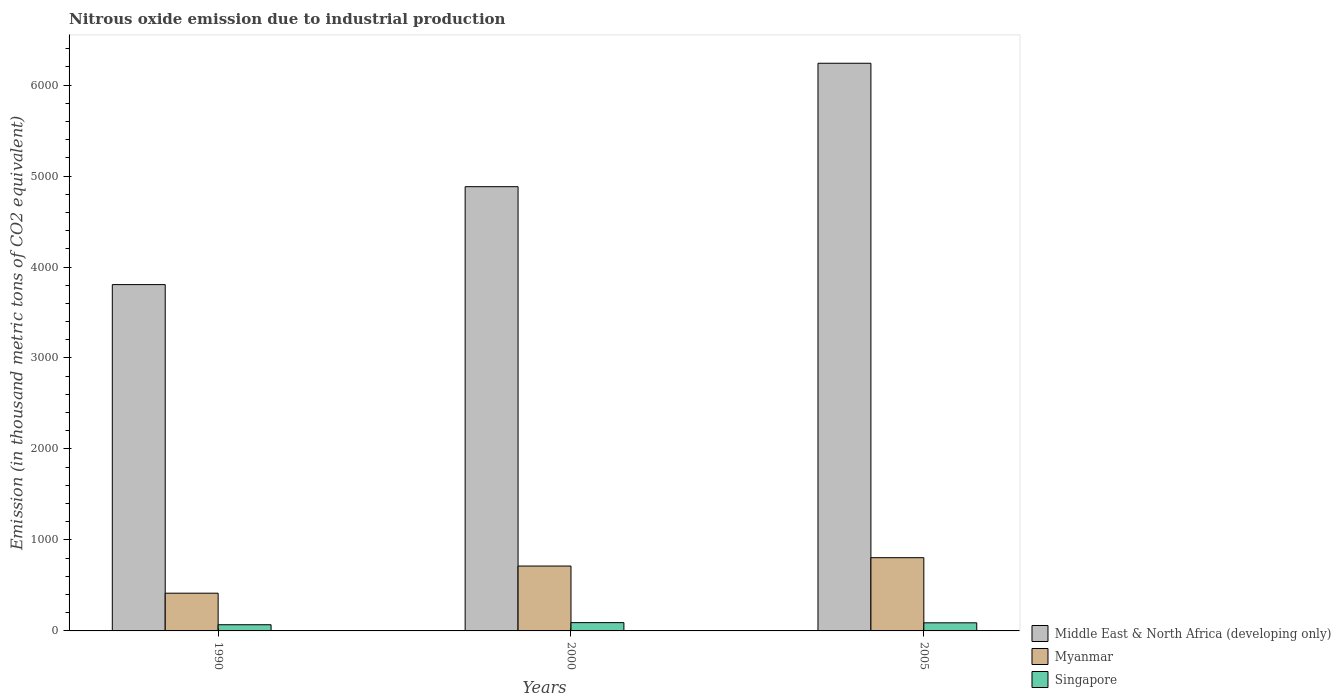How many groups of bars are there?
Provide a short and direct response. 3. Are the number of bars per tick equal to the number of legend labels?
Your response must be concise. Yes. Are the number of bars on each tick of the X-axis equal?
Your response must be concise. Yes. How many bars are there on the 1st tick from the left?
Ensure brevity in your answer.  3. How many bars are there on the 2nd tick from the right?
Your answer should be compact. 3. In how many cases, is the number of bars for a given year not equal to the number of legend labels?
Your response must be concise. 0. What is the amount of nitrous oxide emitted in Middle East & North Africa (developing only) in 2000?
Your response must be concise. 4882.9. Across all years, what is the maximum amount of nitrous oxide emitted in Myanmar?
Give a very brief answer. 804.8. Across all years, what is the minimum amount of nitrous oxide emitted in Middle East & North Africa (developing only)?
Offer a terse response. 3806.6. In which year was the amount of nitrous oxide emitted in Singapore maximum?
Give a very brief answer. 2000. What is the total amount of nitrous oxide emitted in Myanmar in the graph?
Give a very brief answer. 1932.6. What is the difference between the amount of nitrous oxide emitted in Singapore in 2000 and that in 2005?
Provide a short and direct response. 2.1. What is the difference between the amount of nitrous oxide emitted in Myanmar in 2000 and the amount of nitrous oxide emitted in Middle East & North Africa (developing only) in 1990?
Provide a succinct answer. -3093.5. What is the average amount of nitrous oxide emitted in Singapore per year?
Provide a succinct answer. 82.67. In the year 1990, what is the difference between the amount of nitrous oxide emitted in Myanmar and amount of nitrous oxide emitted in Middle East & North Africa (developing only)?
Give a very brief answer. -3391.9. In how many years, is the amount of nitrous oxide emitted in Middle East & North Africa (developing only) greater than 3000 thousand metric tons?
Offer a terse response. 3. What is the ratio of the amount of nitrous oxide emitted in Middle East & North Africa (developing only) in 1990 to that in 2005?
Keep it short and to the point. 0.61. Is the amount of nitrous oxide emitted in Myanmar in 1990 less than that in 2000?
Your answer should be very brief. Yes. What is the difference between the highest and the second highest amount of nitrous oxide emitted in Myanmar?
Offer a terse response. 91.7. What is the difference between the highest and the lowest amount of nitrous oxide emitted in Myanmar?
Make the answer very short. 390.1. What does the 3rd bar from the left in 2000 represents?
Your answer should be compact. Singapore. What does the 2nd bar from the right in 2005 represents?
Keep it short and to the point. Myanmar. Is it the case that in every year, the sum of the amount of nitrous oxide emitted in Singapore and amount of nitrous oxide emitted in Myanmar is greater than the amount of nitrous oxide emitted in Middle East & North Africa (developing only)?
Your answer should be very brief. No. Are all the bars in the graph horizontal?
Ensure brevity in your answer.  No. How many years are there in the graph?
Your answer should be very brief. 3. What is the difference between two consecutive major ticks on the Y-axis?
Provide a succinct answer. 1000. Does the graph contain grids?
Keep it short and to the point. No. What is the title of the graph?
Offer a very short reply. Nitrous oxide emission due to industrial production. Does "Romania" appear as one of the legend labels in the graph?
Give a very brief answer. No. What is the label or title of the X-axis?
Offer a very short reply. Years. What is the label or title of the Y-axis?
Ensure brevity in your answer.  Emission (in thousand metric tons of CO2 equivalent). What is the Emission (in thousand metric tons of CO2 equivalent) in Middle East & North Africa (developing only) in 1990?
Your response must be concise. 3806.6. What is the Emission (in thousand metric tons of CO2 equivalent) in Myanmar in 1990?
Your answer should be very brief. 414.7. What is the Emission (in thousand metric tons of CO2 equivalent) of Singapore in 1990?
Provide a succinct answer. 67.9. What is the Emission (in thousand metric tons of CO2 equivalent) of Middle East & North Africa (developing only) in 2000?
Your answer should be compact. 4882.9. What is the Emission (in thousand metric tons of CO2 equivalent) of Myanmar in 2000?
Offer a very short reply. 713.1. What is the Emission (in thousand metric tons of CO2 equivalent) of Singapore in 2000?
Ensure brevity in your answer.  91.1. What is the Emission (in thousand metric tons of CO2 equivalent) of Middle East & North Africa (developing only) in 2005?
Provide a short and direct response. 6239.6. What is the Emission (in thousand metric tons of CO2 equivalent) in Myanmar in 2005?
Your answer should be very brief. 804.8. What is the Emission (in thousand metric tons of CO2 equivalent) of Singapore in 2005?
Your response must be concise. 89. Across all years, what is the maximum Emission (in thousand metric tons of CO2 equivalent) in Middle East & North Africa (developing only)?
Provide a short and direct response. 6239.6. Across all years, what is the maximum Emission (in thousand metric tons of CO2 equivalent) in Myanmar?
Keep it short and to the point. 804.8. Across all years, what is the maximum Emission (in thousand metric tons of CO2 equivalent) of Singapore?
Keep it short and to the point. 91.1. Across all years, what is the minimum Emission (in thousand metric tons of CO2 equivalent) in Middle East & North Africa (developing only)?
Provide a succinct answer. 3806.6. Across all years, what is the minimum Emission (in thousand metric tons of CO2 equivalent) of Myanmar?
Make the answer very short. 414.7. Across all years, what is the minimum Emission (in thousand metric tons of CO2 equivalent) in Singapore?
Provide a succinct answer. 67.9. What is the total Emission (in thousand metric tons of CO2 equivalent) in Middle East & North Africa (developing only) in the graph?
Make the answer very short. 1.49e+04. What is the total Emission (in thousand metric tons of CO2 equivalent) of Myanmar in the graph?
Ensure brevity in your answer.  1932.6. What is the total Emission (in thousand metric tons of CO2 equivalent) of Singapore in the graph?
Keep it short and to the point. 248. What is the difference between the Emission (in thousand metric tons of CO2 equivalent) in Middle East & North Africa (developing only) in 1990 and that in 2000?
Make the answer very short. -1076.3. What is the difference between the Emission (in thousand metric tons of CO2 equivalent) of Myanmar in 1990 and that in 2000?
Give a very brief answer. -298.4. What is the difference between the Emission (in thousand metric tons of CO2 equivalent) of Singapore in 1990 and that in 2000?
Provide a short and direct response. -23.2. What is the difference between the Emission (in thousand metric tons of CO2 equivalent) in Middle East & North Africa (developing only) in 1990 and that in 2005?
Keep it short and to the point. -2433. What is the difference between the Emission (in thousand metric tons of CO2 equivalent) in Myanmar in 1990 and that in 2005?
Give a very brief answer. -390.1. What is the difference between the Emission (in thousand metric tons of CO2 equivalent) in Singapore in 1990 and that in 2005?
Provide a short and direct response. -21.1. What is the difference between the Emission (in thousand metric tons of CO2 equivalent) of Middle East & North Africa (developing only) in 2000 and that in 2005?
Offer a very short reply. -1356.7. What is the difference between the Emission (in thousand metric tons of CO2 equivalent) of Myanmar in 2000 and that in 2005?
Offer a very short reply. -91.7. What is the difference between the Emission (in thousand metric tons of CO2 equivalent) of Middle East & North Africa (developing only) in 1990 and the Emission (in thousand metric tons of CO2 equivalent) of Myanmar in 2000?
Provide a succinct answer. 3093.5. What is the difference between the Emission (in thousand metric tons of CO2 equivalent) in Middle East & North Africa (developing only) in 1990 and the Emission (in thousand metric tons of CO2 equivalent) in Singapore in 2000?
Offer a terse response. 3715.5. What is the difference between the Emission (in thousand metric tons of CO2 equivalent) of Myanmar in 1990 and the Emission (in thousand metric tons of CO2 equivalent) of Singapore in 2000?
Keep it short and to the point. 323.6. What is the difference between the Emission (in thousand metric tons of CO2 equivalent) of Middle East & North Africa (developing only) in 1990 and the Emission (in thousand metric tons of CO2 equivalent) of Myanmar in 2005?
Your answer should be compact. 3001.8. What is the difference between the Emission (in thousand metric tons of CO2 equivalent) of Middle East & North Africa (developing only) in 1990 and the Emission (in thousand metric tons of CO2 equivalent) of Singapore in 2005?
Offer a terse response. 3717.6. What is the difference between the Emission (in thousand metric tons of CO2 equivalent) of Myanmar in 1990 and the Emission (in thousand metric tons of CO2 equivalent) of Singapore in 2005?
Provide a short and direct response. 325.7. What is the difference between the Emission (in thousand metric tons of CO2 equivalent) in Middle East & North Africa (developing only) in 2000 and the Emission (in thousand metric tons of CO2 equivalent) in Myanmar in 2005?
Your answer should be very brief. 4078.1. What is the difference between the Emission (in thousand metric tons of CO2 equivalent) in Middle East & North Africa (developing only) in 2000 and the Emission (in thousand metric tons of CO2 equivalent) in Singapore in 2005?
Offer a terse response. 4793.9. What is the difference between the Emission (in thousand metric tons of CO2 equivalent) of Myanmar in 2000 and the Emission (in thousand metric tons of CO2 equivalent) of Singapore in 2005?
Offer a terse response. 624.1. What is the average Emission (in thousand metric tons of CO2 equivalent) in Middle East & North Africa (developing only) per year?
Your answer should be very brief. 4976.37. What is the average Emission (in thousand metric tons of CO2 equivalent) of Myanmar per year?
Offer a terse response. 644.2. What is the average Emission (in thousand metric tons of CO2 equivalent) in Singapore per year?
Your answer should be compact. 82.67. In the year 1990, what is the difference between the Emission (in thousand metric tons of CO2 equivalent) in Middle East & North Africa (developing only) and Emission (in thousand metric tons of CO2 equivalent) in Myanmar?
Make the answer very short. 3391.9. In the year 1990, what is the difference between the Emission (in thousand metric tons of CO2 equivalent) of Middle East & North Africa (developing only) and Emission (in thousand metric tons of CO2 equivalent) of Singapore?
Keep it short and to the point. 3738.7. In the year 1990, what is the difference between the Emission (in thousand metric tons of CO2 equivalent) of Myanmar and Emission (in thousand metric tons of CO2 equivalent) of Singapore?
Your answer should be compact. 346.8. In the year 2000, what is the difference between the Emission (in thousand metric tons of CO2 equivalent) in Middle East & North Africa (developing only) and Emission (in thousand metric tons of CO2 equivalent) in Myanmar?
Provide a short and direct response. 4169.8. In the year 2000, what is the difference between the Emission (in thousand metric tons of CO2 equivalent) of Middle East & North Africa (developing only) and Emission (in thousand metric tons of CO2 equivalent) of Singapore?
Keep it short and to the point. 4791.8. In the year 2000, what is the difference between the Emission (in thousand metric tons of CO2 equivalent) in Myanmar and Emission (in thousand metric tons of CO2 equivalent) in Singapore?
Ensure brevity in your answer.  622. In the year 2005, what is the difference between the Emission (in thousand metric tons of CO2 equivalent) of Middle East & North Africa (developing only) and Emission (in thousand metric tons of CO2 equivalent) of Myanmar?
Your answer should be compact. 5434.8. In the year 2005, what is the difference between the Emission (in thousand metric tons of CO2 equivalent) in Middle East & North Africa (developing only) and Emission (in thousand metric tons of CO2 equivalent) in Singapore?
Provide a succinct answer. 6150.6. In the year 2005, what is the difference between the Emission (in thousand metric tons of CO2 equivalent) in Myanmar and Emission (in thousand metric tons of CO2 equivalent) in Singapore?
Keep it short and to the point. 715.8. What is the ratio of the Emission (in thousand metric tons of CO2 equivalent) in Middle East & North Africa (developing only) in 1990 to that in 2000?
Offer a very short reply. 0.78. What is the ratio of the Emission (in thousand metric tons of CO2 equivalent) of Myanmar in 1990 to that in 2000?
Make the answer very short. 0.58. What is the ratio of the Emission (in thousand metric tons of CO2 equivalent) in Singapore in 1990 to that in 2000?
Keep it short and to the point. 0.75. What is the ratio of the Emission (in thousand metric tons of CO2 equivalent) of Middle East & North Africa (developing only) in 1990 to that in 2005?
Keep it short and to the point. 0.61. What is the ratio of the Emission (in thousand metric tons of CO2 equivalent) in Myanmar in 1990 to that in 2005?
Keep it short and to the point. 0.52. What is the ratio of the Emission (in thousand metric tons of CO2 equivalent) in Singapore in 1990 to that in 2005?
Offer a very short reply. 0.76. What is the ratio of the Emission (in thousand metric tons of CO2 equivalent) of Middle East & North Africa (developing only) in 2000 to that in 2005?
Keep it short and to the point. 0.78. What is the ratio of the Emission (in thousand metric tons of CO2 equivalent) of Myanmar in 2000 to that in 2005?
Ensure brevity in your answer.  0.89. What is the ratio of the Emission (in thousand metric tons of CO2 equivalent) in Singapore in 2000 to that in 2005?
Give a very brief answer. 1.02. What is the difference between the highest and the second highest Emission (in thousand metric tons of CO2 equivalent) in Middle East & North Africa (developing only)?
Offer a very short reply. 1356.7. What is the difference between the highest and the second highest Emission (in thousand metric tons of CO2 equivalent) in Myanmar?
Offer a very short reply. 91.7. What is the difference between the highest and the second highest Emission (in thousand metric tons of CO2 equivalent) of Singapore?
Ensure brevity in your answer.  2.1. What is the difference between the highest and the lowest Emission (in thousand metric tons of CO2 equivalent) in Middle East & North Africa (developing only)?
Make the answer very short. 2433. What is the difference between the highest and the lowest Emission (in thousand metric tons of CO2 equivalent) of Myanmar?
Make the answer very short. 390.1. What is the difference between the highest and the lowest Emission (in thousand metric tons of CO2 equivalent) of Singapore?
Ensure brevity in your answer.  23.2. 